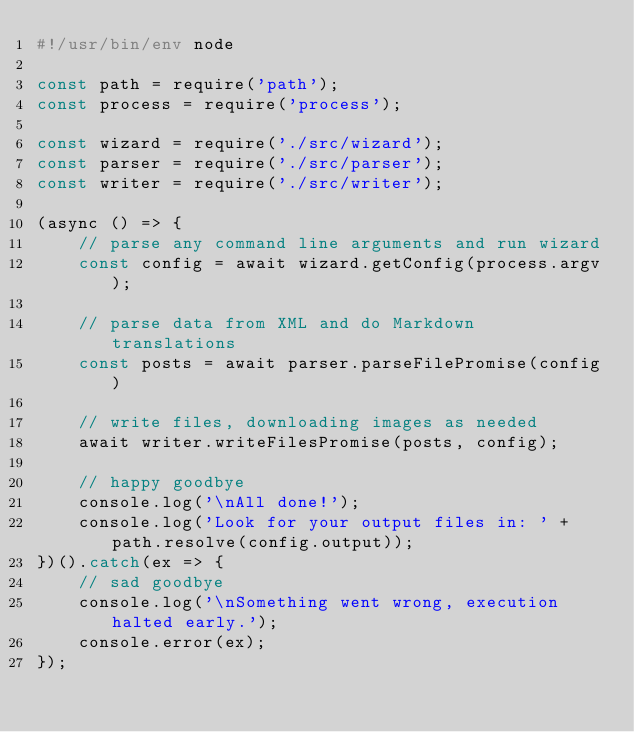Convert code to text. <code><loc_0><loc_0><loc_500><loc_500><_JavaScript_>#!/usr/bin/env node

const path = require('path');
const process = require('process');

const wizard = require('./src/wizard');
const parser = require('./src/parser');
const writer = require('./src/writer');

(async () => {
	// parse any command line arguments and run wizard
	const config = await wizard.getConfig(process.argv);

	// parse data from XML and do Markdown translations
	const posts = await parser.parseFilePromise(config)

	// write files, downloading images as needed
	await writer.writeFilesPromise(posts, config);

	// happy goodbye
	console.log('\nAll done!');
	console.log('Look for your output files in: ' + path.resolve(config.output));
})().catch(ex => {
	// sad goodbye
	console.log('\nSomething went wrong, execution halted early.');
	console.error(ex);
});
</code> 